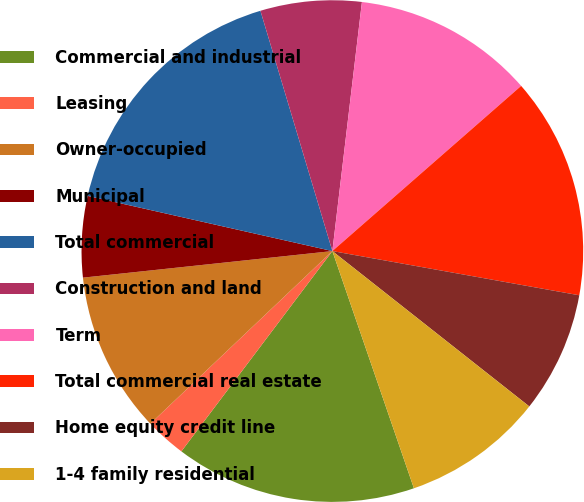<chart> <loc_0><loc_0><loc_500><loc_500><pie_chart><fcel>Commercial and industrial<fcel>Leasing<fcel>Owner-occupied<fcel>Municipal<fcel>Total commercial<fcel>Construction and land<fcel>Term<fcel>Total commercial real estate<fcel>Home equity credit line<fcel>1-4 family residential<nl><fcel>15.55%<fcel>2.64%<fcel>10.39%<fcel>5.22%<fcel>16.84%<fcel>6.51%<fcel>11.68%<fcel>14.26%<fcel>7.81%<fcel>9.1%<nl></chart> 